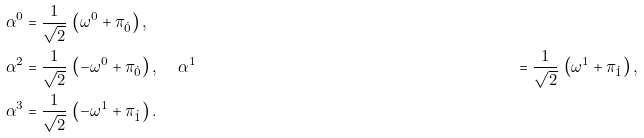Convert formula to latex. <formula><loc_0><loc_0><loc_500><loc_500>\alpha ^ { 0 } & = \frac { 1 } { \sqrt { 2 } } \, \left ( \omega ^ { 0 } + \pi _ { \dot { 0 } } \right ) , \\ \alpha ^ { 2 } & = \frac { 1 } { \sqrt { 2 } } \, \left ( - \omega ^ { 0 } + \pi _ { \dot { 0 } } \right ) , \quad \, \alpha ^ { 1 } & = \frac { 1 } { \sqrt { 2 } } \, \left ( \omega ^ { 1 } + \pi _ { \dot { 1 } } \right ) , \\ \alpha ^ { 3 } & = \frac { 1 } { \sqrt { 2 } } \, \left ( - \omega ^ { 1 } + \pi _ { \dot { 1 } } \right ) .</formula> 